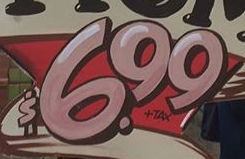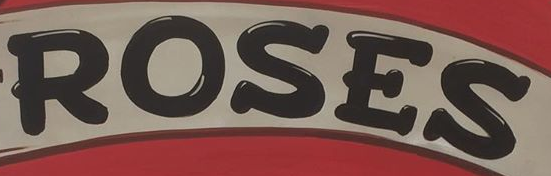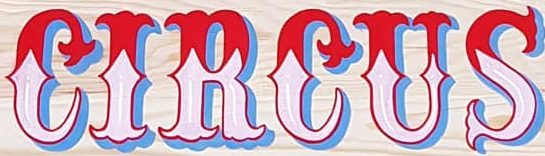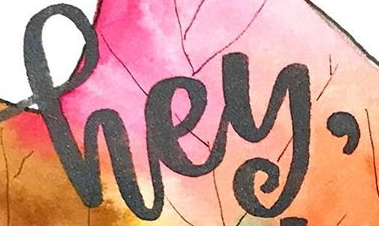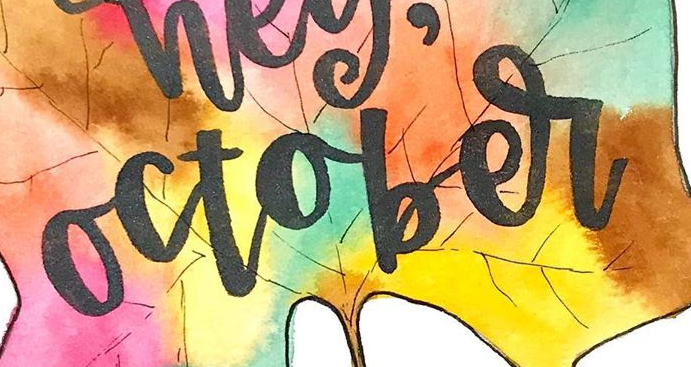What text is displayed in these images sequentially, separated by a semicolon? $6.99; ROSES; CIRCUS; hey,; october 